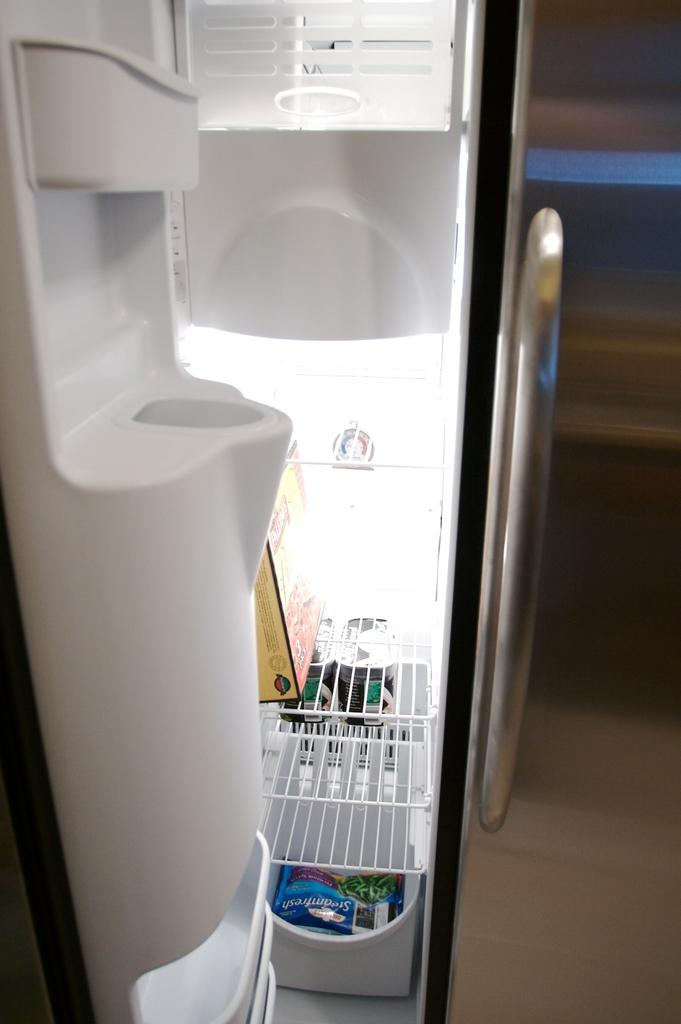<image>
Summarize the visual content of the image. A refrigerator that has a box with the digit 3 on the top shelf. 